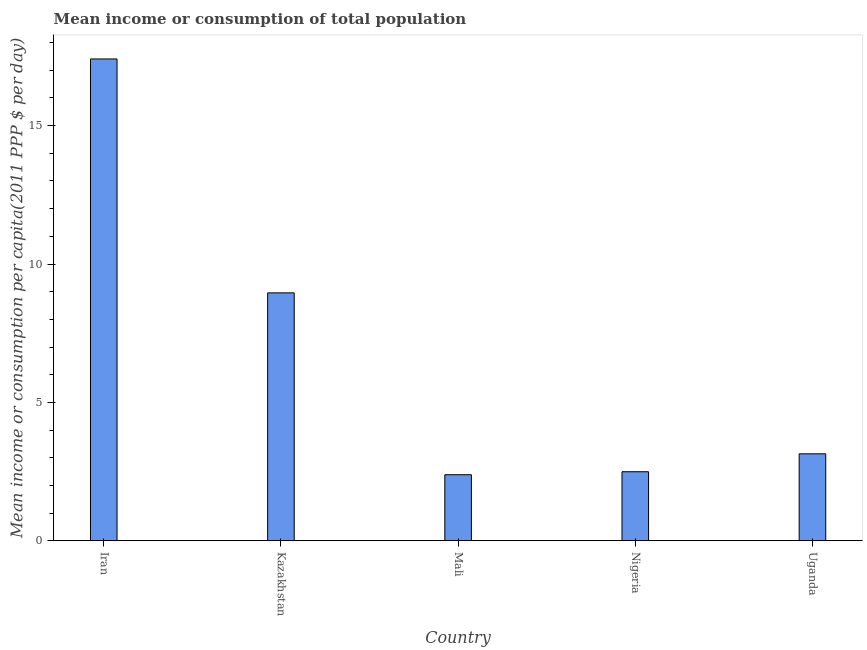Does the graph contain any zero values?
Your response must be concise. No. Does the graph contain grids?
Make the answer very short. No. What is the title of the graph?
Offer a very short reply. Mean income or consumption of total population. What is the label or title of the X-axis?
Your response must be concise. Country. What is the label or title of the Y-axis?
Offer a terse response. Mean income or consumption per capita(2011 PPP $ per day). What is the mean income or consumption in Mali?
Your response must be concise. 2.38. Across all countries, what is the maximum mean income or consumption?
Offer a terse response. 17.41. Across all countries, what is the minimum mean income or consumption?
Your response must be concise. 2.38. In which country was the mean income or consumption maximum?
Make the answer very short. Iran. In which country was the mean income or consumption minimum?
Your answer should be compact. Mali. What is the sum of the mean income or consumption?
Offer a terse response. 34.39. What is the difference between the mean income or consumption in Iran and Uganda?
Ensure brevity in your answer.  14.27. What is the average mean income or consumption per country?
Your answer should be very brief. 6.88. What is the median mean income or consumption?
Your response must be concise. 3.14. What is the ratio of the mean income or consumption in Nigeria to that in Uganda?
Provide a succinct answer. 0.79. Is the mean income or consumption in Iran less than that in Kazakhstan?
Make the answer very short. No. Is the difference between the mean income or consumption in Iran and Nigeria greater than the difference between any two countries?
Offer a very short reply. No. What is the difference between the highest and the second highest mean income or consumption?
Your answer should be compact. 8.45. What is the difference between the highest and the lowest mean income or consumption?
Give a very brief answer. 15.03. In how many countries, is the mean income or consumption greater than the average mean income or consumption taken over all countries?
Give a very brief answer. 2. How many bars are there?
Give a very brief answer. 5. Are all the bars in the graph horizontal?
Ensure brevity in your answer.  No. How many countries are there in the graph?
Make the answer very short. 5. Are the values on the major ticks of Y-axis written in scientific E-notation?
Keep it short and to the point. No. What is the Mean income or consumption per capita(2011 PPP $ per day) of Iran?
Ensure brevity in your answer.  17.41. What is the Mean income or consumption per capita(2011 PPP $ per day) in Kazakhstan?
Give a very brief answer. 8.96. What is the Mean income or consumption per capita(2011 PPP $ per day) of Mali?
Your answer should be very brief. 2.38. What is the Mean income or consumption per capita(2011 PPP $ per day) of Nigeria?
Your answer should be compact. 2.49. What is the Mean income or consumption per capita(2011 PPP $ per day) in Uganda?
Ensure brevity in your answer.  3.14. What is the difference between the Mean income or consumption per capita(2011 PPP $ per day) in Iran and Kazakhstan?
Give a very brief answer. 8.45. What is the difference between the Mean income or consumption per capita(2011 PPP $ per day) in Iran and Mali?
Provide a succinct answer. 15.03. What is the difference between the Mean income or consumption per capita(2011 PPP $ per day) in Iran and Nigeria?
Your response must be concise. 14.92. What is the difference between the Mean income or consumption per capita(2011 PPP $ per day) in Iran and Uganda?
Offer a very short reply. 14.27. What is the difference between the Mean income or consumption per capita(2011 PPP $ per day) in Kazakhstan and Mali?
Provide a succinct answer. 6.57. What is the difference between the Mean income or consumption per capita(2011 PPP $ per day) in Kazakhstan and Nigeria?
Keep it short and to the point. 6.46. What is the difference between the Mean income or consumption per capita(2011 PPP $ per day) in Kazakhstan and Uganda?
Ensure brevity in your answer.  5.82. What is the difference between the Mean income or consumption per capita(2011 PPP $ per day) in Mali and Nigeria?
Your answer should be very brief. -0.11. What is the difference between the Mean income or consumption per capita(2011 PPP $ per day) in Mali and Uganda?
Offer a terse response. -0.76. What is the difference between the Mean income or consumption per capita(2011 PPP $ per day) in Nigeria and Uganda?
Your answer should be very brief. -0.65. What is the ratio of the Mean income or consumption per capita(2011 PPP $ per day) in Iran to that in Kazakhstan?
Ensure brevity in your answer.  1.94. What is the ratio of the Mean income or consumption per capita(2011 PPP $ per day) in Iran to that in Nigeria?
Ensure brevity in your answer.  6.98. What is the ratio of the Mean income or consumption per capita(2011 PPP $ per day) in Iran to that in Uganda?
Your response must be concise. 5.54. What is the ratio of the Mean income or consumption per capita(2011 PPP $ per day) in Kazakhstan to that in Mali?
Provide a succinct answer. 3.76. What is the ratio of the Mean income or consumption per capita(2011 PPP $ per day) in Kazakhstan to that in Nigeria?
Ensure brevity in your answer.  3.59. What is the ratio of the Mean income or consumption per capita(2011 PPP $ per day) in Kazakhstan to that in Uganda?
Offer a terse response. 2.85. What is the ratio of the Mean income or consumption per capita(2011 PPP $ per day) in Mali to that in Nigeria?
Give a very brief answer. 0.96. What is the ratio of the Mean income or consumption per capita(2011 PPP $ per day) in Mali to that in Uganda?
Keep it short and to the point. 0.76. What is the ratio of the Mean income or consumption per capita(2011 PPP $ per day) in Nigeria to that in Uganda?
Your response must be concise. 0.79. 